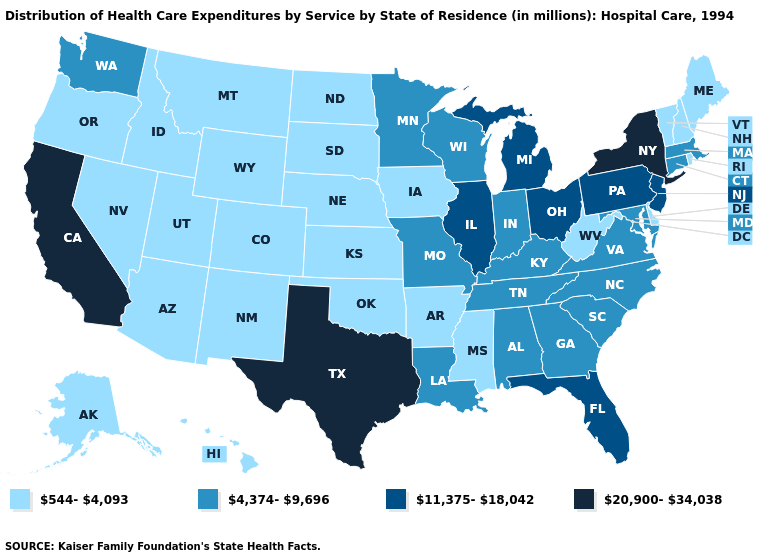Name the states that have a value in the range 4,374-9,696?
Be succinct. Alabama, Connecticut, Georgia, Indiana, Kentucky, Louisiana, Maryland, Massachusetts, Minnesota, Missouri, North Carolina, South Carolina, Tennessee, Virginia, Washington, Wisconsin. Does Texas have the highest value in the USA?
Give a very brief answer. Yes. Does the first symbol in the legend represent the smallest category?
Quick response, please. Yes. Among the states that border Colorado , which have the lowest value?
Quick response, please. Arizona, Kansas, Nebraska, New Mexico, Oklahoma, Utah, Wyoming. Does the map have missing data?
Write a very short answer. No. What is the value of Maryland?
Write a very short answer. 4,374-9,696. What is the value of Arkansas?
Quick response, please. 544-4,093. Name the states that have a value in the range 20,900-34,038?
Keep it brief. California, New York, Texas. Does Nevada have the same value as Oregon?
Answer briefly. Yes. Does Arkansas have the lowest value in the South?
Write a very short answer. Yes. Among the states that border Arkansas , which have the highest value?
Short answer required. Texas. Name the states that have a value in the range 20,900-34,038?
Be succinct. California, New York, Texas. What is the lowest value in states that border New Hampshire?
Be succinct. 544-4,093. Name the states that have a value in the range 20,900-34,038?
Short answer required. California, New York, Texas. Name the states that have a value in the range 20,900-34,038?
Concise answer only. California, New York, Texas. 